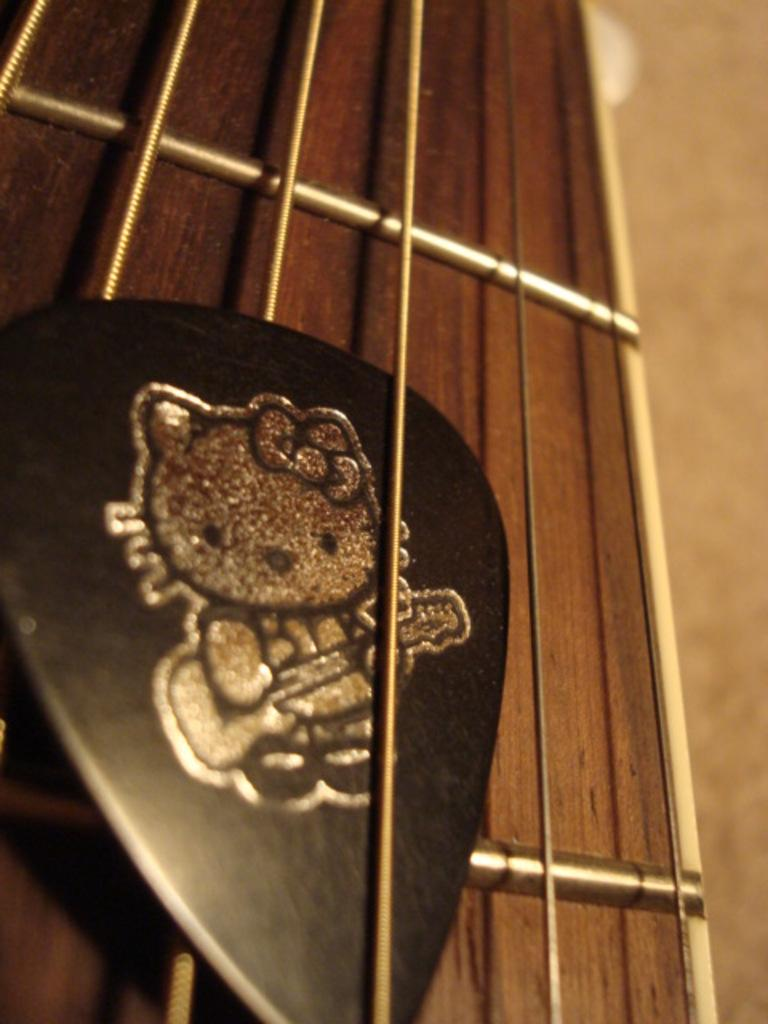What object is featured in the image? There is a guitar stick in the image. What is depicted on the guitar stick? The guitar stick has an image on it. What color are the strings on the guitar? The guitar strings are gold-colored. What is the color of the background in the image? The background of the image is brown in color. How does the guitar feel about playing chess in the image? The image does not depict the guitar playing chess or expressing any feelings, as it is an inanimate object. 